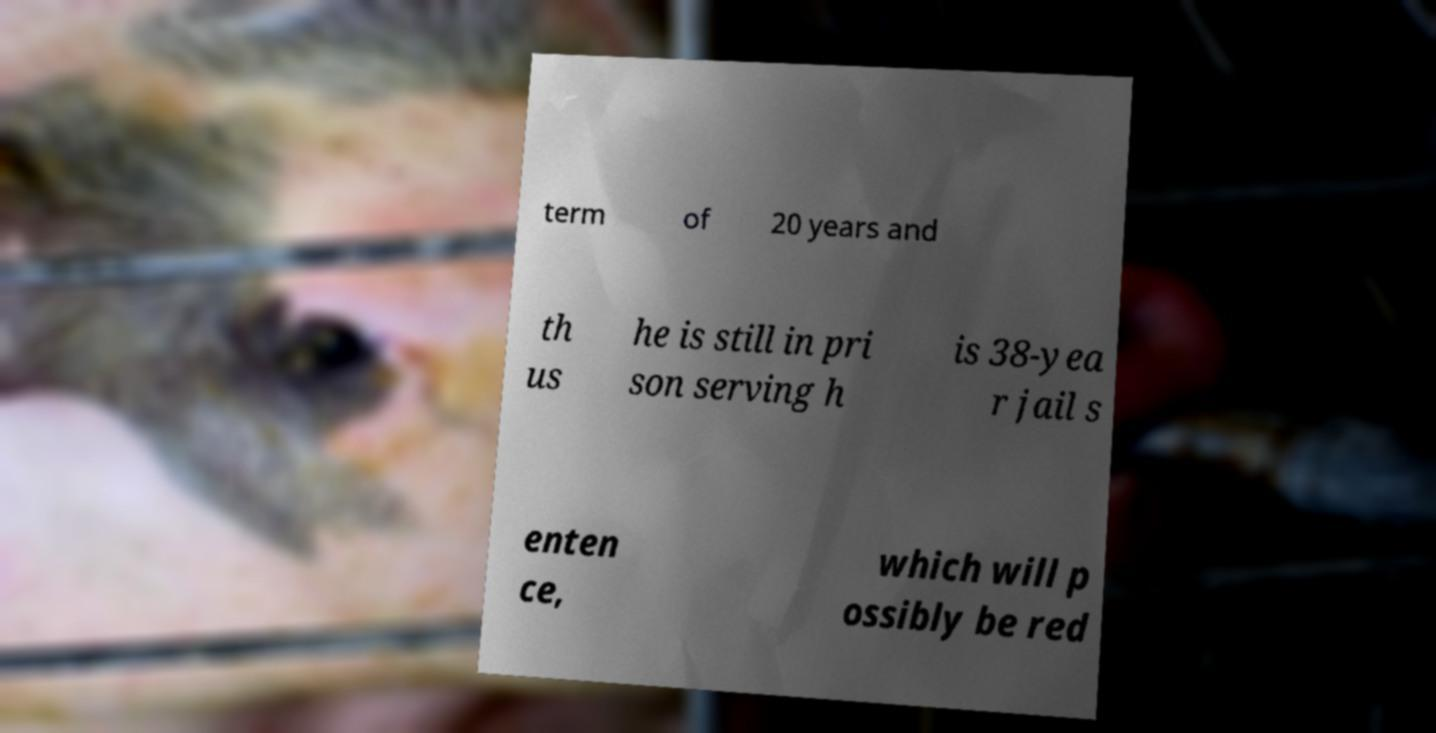Could you extract and type out the text from this image? term of 20 years and th us he is still in pri son serving h is 38-yea r jail s enten ce, which will p ossibly be red 